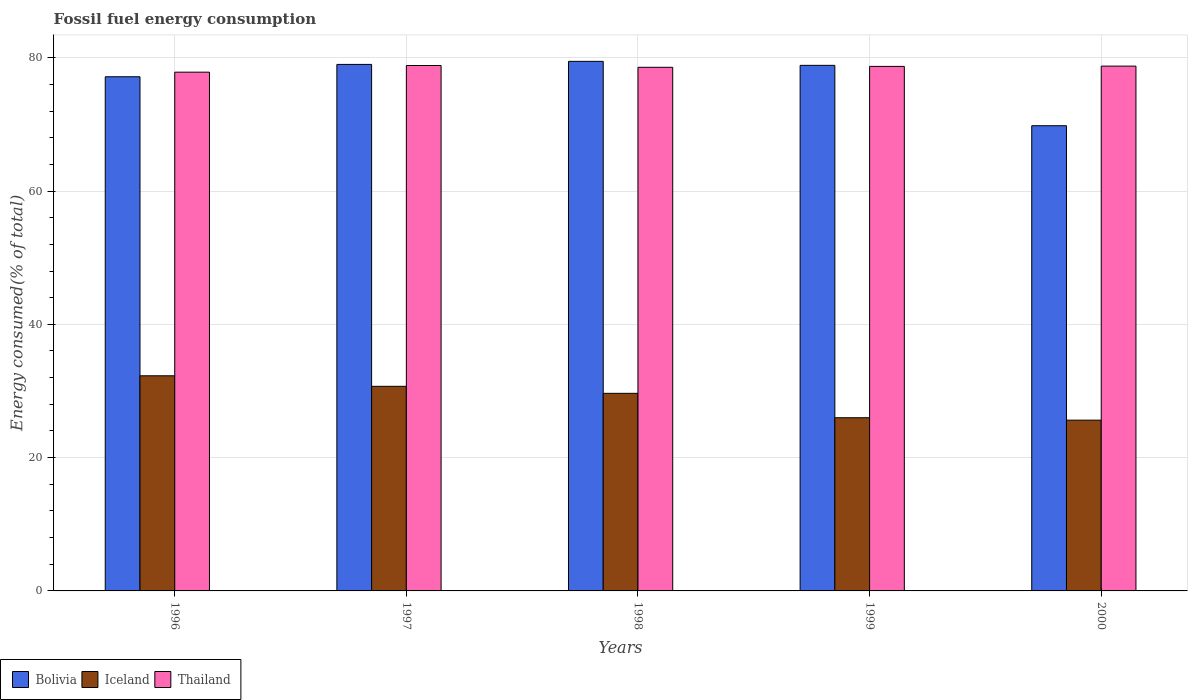How many different coloured bars are there?
Your answer should be compact. 3. How many bars are there on the 3rd tick from the left?
Your answer should be very brief. 3. How many bars are there on the 4th tick from the right?
Provide a succinct answer. 3. In how many cases, is the number of bars for a given year not equal to the number of legend labels?
Give a very brief answer. 0. What is the percentage of energy consumed in Thailand in 2000?
Keep it short and to the point. 78.74. Across all years, what is the maximum percentage of energy consumed in Thailand?
Keep it short and to the point. 78.84. Across all years, what is the minimum percentage of energy consumed in Iceland?
Provide a succinct answer. 25.62. In which year was the percentage of energy consumed in Iceland maximum?
Make the answer very short. 1996. In which year was the percentage of energy consumed in Iceland minimum?
Give a very brief answer. 2000. What is the total percentage of energy consumed in Bolivia in the graph?
Make the answer very short. 384.27. What is the difference between the percentage of energy consumed in Thailand in 1999 and that in 2000?
Offer a very short reply. -0.04. What is the difference between the percentage of energy consumed in Bolivia in 1997 and the percentage of energy consumed in Iceland in 1996?
Provide a short and direct response. 46.72. What is the average percentage of energy consumed in Bolivia per year?
Offer a very short reply. 76.85. In the year 1997, what is the difference between the percentage of energy consumed in Iceland and percentage of energy consumed in Bolivia?
Provide a short and direct response. -48.3. What is the ratio of the percentage of energy consumed in Bolivia in 1996 to that in 1997?
Provide a short and direct response. 0.98. Is the percentage of energy consumed in Thailand in 1996 less than that in 2000?
Offer a very short reply. Yes. What is the difference between the highest and the second highest percentage of energy consumed in Bolivia?
Make the answer very short. 0.46. What is the difference between the highest and the lowest percentage of energy consumed in Thailand?
Ensure brevity in your answer.  1. What does the 3rd bar from the left in 1998 represents?
Offer a very short reply. Thailand. Is it the case that in every year, the sum of the percentage of energy consumed in Thailand and percentage of energy consumed in Bolivia is greater than the percentage of energy consumed in Iceland?
Give a very brief answer. Yes. How many years are there in the graph?
Ensure brevity in your answer.  5. What is the difference between two consecutive major ticks on the Y-axis?
Give a very brief answer. 20. Does the graph contain any zero values?
Provide a succinct answer. No. Does the graph contain grids?
Offer a terse response. Yes. Where does the legend appear in the graph?
Ensure brevity in your answer.  Bottom left. How are the legend labels stacked?
Provide a succinct answer. Horizontal. What is the title of the graph?
Provide a succinct answer. Fossil fuel energy consumption. Does "Micronesia" appear as one of the legend labels in the graph?
Make the answer very short. No. What is the label or title of the Y-axis?
Make the answer very short. Energy consumed(% of total). What is the Energy consumed(% of total) in Bolivia in 1996?
Provide a succinct answer. 77.15. What is the Energy consumed(% of total) of Iceland in 1996?
Make the answer very short. 32.28. What is the Energy consumed(% of total) of Thailand in 1996?
Offer a terse response. 77.84. What is the Energy consumed(% of total) in Bolivia in 1997?
Offer a terse response. 79. What is the Energy consumed(% of total) of Iceland in 1997?
Provide a short and direct response. 30.7. What is the Energy consumed(% of total) in Thailand in 1997?
Offer a terse response. 78.84. What is the Energy consumed(% of total) of Bolivia in 1998?
Your response must be concise. 79.46. What is the Energy consumed(% of total) of Iceland in 1998?
Your answer should be compact. 29.65. What is the Energy consumed(% of total) of Thailand in 1998?
Offer a very short reply. 78.57. What is the Energy consumed(% of total) in Bolivia in 1999?
Your response must be concise. 78.86. What is the Energy consumed(% of total) in Iceland in 1999?
Provide a succinct answer. 25.99. What is the Energy consumed(% of total) of Thailand in 1999?
Give a very brief answer. 78.7. What is the Energy consumed(% of total) of Bolivia in 2000?
Provide a short and direct response. 69.8. What is the Energy consumed(% of total) in Iceland in 2000?
Provide a succinct answer. 25.62. What is the Energy consumed(% of total) in Thailand in 2000?
Your answer should be compact. 78.74. Across all years, what is the maximum Energy consumed(% of total) of Bolivia?
Your answer should be compact. 79.46. Across all years, what is the maximum Energy consumed(% of total) in Iceland?
Your answer should be compact. 32.28. Across all years, what is the maximum Energy consumed(% of total) of Thailand?
Ensure brevity in your answer.  78.84. Across all years, what is the minimum Energy consumed(% of total) of Bolivia?
Provide a short and direct response. 69.8. Across all years, what is the minimum Energy consumed(% of total) of Iceland?
Provide a short and direct response. 25.62. Across all years, what is the minimum Energy consumed(% of total) of Thailand?
Make the answer very short. 77.84. What is the total Energy consumed(% of total) of Bolivia in the graph?
Make the answer very short. 384.27. What is the total Energy consumed(% of total) of Iceland in the graph?
Give a very brief answer. 144.24. What is the total Energy consumed(% of total) of Thailand in the graph?
Your response must be concise. 392.68. What is the difference between the Energy consumed(% of total) of Bolivia in 1996 and that in 1997?
Your answer should be compact. -1.85. What is the difference between the Energy consumed(% of total) of Iceland in 1996 and that in 1997?
Your response must be concise. 1.58. What is the difference between the Energy consumed(% of total) of Thailand in 1996 and that in 1997?
Give a very brief answer. -1. What is the difference between the Energy consumed(% of total) in Bolivia in 1996 and that in 1998?
Provide a succinct answer. -2.31. What is the difference between the Energy consumed(% of total) of Iceland in 1996 and that in 1998?
Your response must be concise. 2.63. What is the difference between the Energy consumed(% of total) in Thailand in 1996 and that in 1998?
Provide a succinct answer. -0.73. What is the difference between the Energy consumed(% of total) in Bolivia in 1996 and that in 1999?
Keep it short and to the point. -1.71. What is the difference between the Energy consumed(% of total) of Iceland in 1996 and that in 1999?
Make the answer very short. 6.29. What is the difference between the Energy consumed(% of total) of Thailand in 1996 and that in 1999?
Provide a short and direct response. -0.87. What is the difference between the Energy consumed(% of total) of Bolivia in 1996 and that in 2000?
Your response must be concise. 7.35. What is the difference between the Energy consumed(% of total) in Iceland in 1996 and that in 2000?
Ensure brevity in your answer.  6.66. What is the difference between the Energy consumed(% of total) of Thailand in 1996 and that in 2000?
Make the answer very short. -0.91. What is the difference between the Energy consumed(% of total) in Bolivia in 1997 and that in 1998?
Offer a very short reply. -0.46. What is the difference between the Energy consumed(% of total) in Iceland in 1997 and that in 1998?
Offer a terse response. 1.05. What is the difference between the Energy consumed(% of total) in Thailand in 1997 and that in 1998?
Keep it short and to the point. 0.27. What is the difference between the Energy consumed(% of total) of Bolivia in 1997 and that in 1999?
Offer a terse response. 0.14. What is the difference between the Energy consumed(% of total) of Iceland in 1997 and that in 1999?
Offer a very short reply. 4.71. What is the difference between the Energy consumed(% of total) in Thailand in 1997 and that in 1999?
Give a very brief answer. 0.13. What is the difference between the Energy consumed(% of total) in Bolivia in 1997 and that in 2000?
Provide a short and direct response. 9.2. What is the difference between the Energy consumed(% of total) of Iceland in 1997 and that in 2000?
Ensure brevity in your answer.  5.08. What is the difference between the Energy consumed(% of total) in Thailand in 1997 and that in 2000?
Your answer should be very brief. 0.09. What is the difference between the Energy consumed(% of total) in Bolivia in 1998 and that in 1999?
Provide a short and direct response. 0.6. What is the difference between the Energy consumed(% of total) in Iceland in 1998 and that in 1999?
Your answer should be compact. 3.66. What is the difference between the Energy consumed(% of total) in Thailand in 1998 and that in 1999?
Keep it short and to the point. -0.14. What is the difference between the Energy consumed(% of total) of Bolivia in 1998 and that in 2000?
Your response must be concise. 9.66. What is the difference between the Energy consumed(% of total) of Iceland in 1998 and that in 2000?
Ensure brevity in your answer.  4.02. What is the difference between the Energy consumed(% of total) of Thailand in 1998 and that in 2000?
Make the answer very short. -0.18. What is the difference between the Energy consumed(% of total) in Bolivia in 1999 and that in 2000?
Offer a terse response. 9.06. What is the difference between the Energy consumed(% of total) in Iceland in 1999 and that in 2000?
Your answer should be compact. 0.37. What is the difference between the Energy consumed(% of total) in Thailand in 1999 and that in 2000?
Offer a terse response. -0.04. What is the difference between the Energy consumed(% of total) in Bolivia in 1996 and the Energy consumed(% of total) in Iceland in 1997?
Make the answer very short. 46.45. What is the difference between the Energy consumed(% of total) of Bolivia in 1996 and the Energy consumed(% of total) of Thailand in 1997?
Ensure brevity in your answer.  -1.69. What is the difference between the Energy consumed(% of total) in Iceland in 1996 and the Energy consumed(% of total) in Thailand in 1997?
Make the answer very short. -46.56. What is the difference between the Energy consumed(% of total) of Bolivia in 1996 and the Energy consumed(% of total) of Iceland in 1998?
Keep it short and to the point. 47.5. What is the difference between the Energy consumed(% of total) in Bolivia in 1996 and the Energy consumed(% of total) in Thailand in 1998?
Your response must be concise. -1.42. What is the difference between the Energy consumed(% of total) in Iceland in 1996 and the Energy consumed(% of total) in Thailand in 1998?
Ensure brevity in your answer.  -46.29. What is the difference between the Energy consumed(% of total) in Bolivia in 1996 and the Energy consumed(% of total) in Iceland in 1999?
Your answer should be compact. 51.16. What is the difference between the Energy consumed(% of total) of Bolivia in 1996 and the Energy consumed(% of total) of Thailand in 1999?
Offer a very short reply. -1.55. What is the difference between the Energy consumed(% of total) of Iceland in 1996 and the Energy consumed(% of total) of Thailand in 1999?
Offer a very short reply. -46.42. What is the difference between the Energy consumed(% of total) in Bolivia in 1996 and the Energy consumed(% of total) in Iceland in 2000?
Keep it short and to the point. 51.52. What is the difference between the Energy consumed(% of total) of Bolivia in 1996 and the Energy consumed(% of total) of Thailand in 2000?
Keep it short and to the point. -1.6. What is the difference between the Energy consumed(% of total) in Iceland in 1996 and the Energy consumed(% of total) in Thailand in 2000?
Your answer should be very brief. -46.46. What is the difference between the Energy consumed(% of total) of Bolivia in 1997 and the Energy consumed(% of total) of Iceland in 1998?
Offer a terse response. 49.35. What is the difference between the Energy consumed(% of total) in Bolivia in 1997 and the Energy consumed(% of total) in Thailand in 1998?
Your response must be concise. 0.43. What is the difference between the Energy consumed(% of total) in Iceland in 1997 and the Energy consumed(% of total) in Thailand in 1998?
Provide a succinct answer. -47.87. What is the difference between the Energy consumed(% of total) in Bolivia in 1997 and the Energy consumed(% of total) in Iceland in 1999?
Your answer should be very brief. 53.01. What is the difference between the Energy consumed(% of total) of Bolivia in 1997 and the Energy consumed(% of total) of Thailand in 1999?
Provide a succinct answer. 0.3. What is the difference between the Energy consumed(% of total) in Iceland in 1997 and the Energy consumed(% of total) in Thailand in 1999?
Ensure brevity in your answer.  -48. What is the difference between the Energy consumed(% of total) in Bolivia in 1997 and the Energy consumed(% of total) in Iceland in 2000?
Provide a short and direct response. 53.38. What is the difference between the Energy consumed(% of total) of Bolivia in 1997 and the Energy consumed(% of total) of Thailand in 2000?
Keep it short and to the point. 0.26. What is the difference between the Energy consumed(% of total) of Iceland in 1997 and the Energy consumed(% of total) of Thailand in 2000?
Provide a short and direct response. -48.04. What is the difference between the Energy consumed(% of total) in Bolivia in 1998 and the Energy consumed(% of total) in Iceland in 1999?
Provide a succinct answer. 53.47. What is the difference between the Energy consumed(% of total) in Bolivia in 1998 and the Energy consumed(% of total) in Thailand in 1999?
Offer a terse response. 0.76. What is the difference between the Energy consumed(% of total) of Iceland in 1998 and the Energy consumed(% of total) of Thailand in 1999?
Provide a short and direct response. -49.05. What is the difference between the Energy consumed(% of total) in Bolivia in 1998 and the Energy consumed(% of total) in Iceland in 2000?
Your answer should be very brief. 53.84. What is the difference between the Energy consumed(% of total) of Bolivia in 1998 and the Energy consumed(% of total) of Thailand in 2000?
Your response must be concise. 0.72. What is the difference between the Energy consumed(% of total) of Iceland in 1998 and the Energy consumed(% of total) of Thailand in 2000?
Your response must be concise. -49.1. What is the difference between the Energy consumed(% of total) of Bolivia in 1999 and the Energy consumed(% of total) of Iceland in 2000?
Ensure brevity in your answer.  53.24. What is the difference between the Energy consumed(% of total) in Bolivia in 1999 and the Energy consumed(% of total) in Thailand in 2000?
Provide a succinct answer. 0.12. What is the difference between the Energy consumed(% of total) in Iceland in 1999 and the Energy consumed(% of total) in Thailand in 2000?
Ensure brevity in your answer.  -52.76. What is the average Energy consumed(% of total) of Bolivia per year?
Offer a terse response. 76.85. What is the average Energy consumed(% of total) in Iceland per year?
Your response must be concise. 28.85. What is the average Energy consumed(% of total) in Thailand per year?
Make the answer very short. 78.54. In the year 1996, what is the difference between the Energy consumed(% of total) in Bolivia and Energy consumed(% of total) in Iceland?
Give a very brief answer. 44.87. In the year 1996, what is the difference between the Energy consumed(% of total) in Bolivia and Energy consumed(% of total) in Thailand?
Make the answer very short. -0.69. In the year 1996, what is the difference between the Energy consumed(% of total) of Iceland and Energy consumed(% of total) of Thailand?
Provide a short and direct response. -45.56. In the year 1997, what is the difference between the Energy consumed(% of total) in Bolivia and Energy consumed(% of total) in Iceland?
Make the answer very short. 48.3. In the year 1997, what is the difference between the Energy consumed(% of total) of Bolivia and Energy consumed(% of total) of Thailand?
Ensure brevity in your answer.  0.16. In the year 1997, what is the difference between the Energy consumed(% of total) of Iceland and Energy consumed(% of total) of Thailand?
Provide a short and direct response. -48.14. In the year 1998, what is the difference between the Energy consumed(% of total) of Bolivia and Energy consumed(% of total) of Iceland?
Offer a very short reply. 49.81. In the year 1998, what is the difference between the Energy consumed(% of total) in Bolivia and Energy consumed(% of total) in Thailand?
Offer a terse response. 0.89. In the year 1998, what is the difference between the Energy consumed(% of total) in Iceland and Energy consumed(% of total) in Thailand?
Offer a terse response. -48.92. In the year 1999, what is the difference between the Energy consumed(% of total) in Bolivia and Energy consumed(% of total) in Iceland?
Your response must be concise. 52.87. In the year 1999, what is the difference between the Energy consumed(% of total) of Bolivia and Energy consumed(% of total) of Thailand?
Provide a succinct answer. 0.16. In the year 1999, what is the difference between the Energy consumed(% of total) of Iceland and Energy consumed(% of total) of Thailand?
Your response must be concise. -52.71. In the year 2000, what is the difference between the Energy consumed(% of total) of Bolivia and Energy consumed(% of total) of Iceland?
Give a very brief answer. 44.18. In the year 2000, what is the difference between the Energy consumed(% of total) of Bolivia and Energy consumed(% of total) of Thailand?
Offer a very short reply. -8.94. In the year 2000, what is the difference between the Energy consumed(% of total) in Iceland and Energy consumed(% of total) in Thailand?
Your answer should be compact. -53.12. What is the ratio of the Energy consumed(% of total) in Bolivia in 1996 to that in 1997?
Your answer should be compact. 0.98. What is the ratio of the Energy consumed(% of total) in Iceland in 1996 to that in 1997?
Your response must be concise. 1.05. What is the ratio of the Energy consumed(% of total) in Thailand in 1996 to that in 1997?
Your answer should be very brief. 0.99. What is the ratio of the Energy consumed(% of total) in Bolivia in 1996 to that in 1998?
Keep it short and to the point. 0.97. What is the ratio of the Energy consumed(% of total) of Iceland in 1996 to that in 1998?
Provide a succinct answer. 1.09. What is the ratio of the Energy consumed(% of total) of Thailand in 1996 to that in 1998?
Your response must be concise. 0.99. What is the ratio of the Energy consumed(% of total) of Bolivia in 1996 to that in 1999?
Your answer should be very brief. 0.98. What is the ratio of the Energy consumed(% of total) in Iceland in 1996 to that in 1999?
Your response must be concise. 1.24. What is the ratio of the Energy consumed(% of total) in Thailand in 1996 to that in 1999?
Provide a short and direct response. 0.99. What is the ratio of the Energy consumed(% of total) of Bolivia in 1996 to that in 2000?
Your answer should be very brief. 1.11. What is the ratio of the Energy consumed(% of total) in Iceland in 1996 to that in 2000?
Offer a very short reply. 1.26. What is the ratio of the Energy consumed(% of total) of Thailand in 1996 to that in 2000?
Your response must be concise. 0.99. What is the ratio of the Energy consumed(% of total) in Bolivia in 1997 to that in 1998?
Offer a very short reply. 0.99. What is the ratio of the Energy consumed(% of total) in Iceland in 1997 to that in 1998?
Offer a very short reply. 1.04. What is the ratio of the Energy consumed(% of total) of Thailand in 1997 to that in 1998?
Provide a succinct answer. 1. What is the ratio of the Energy consumed(% of total) of Bolivia in 1997 to that in 1999?
Ensure brevity in your answer.  1. What is the ratio of the Energy consumed(% of total) in Iceland in 1997 to that in 1999?
Offer a terse response. 1.18. What is the ratio of the Energy consumed(% of total) of Bolivia in 1997 to that in 2000?
Offer a very short reply. 1.13. What is the ratio of the Energy consumed(% of total) in Iceland in 1997 to that in 2000?
Provide a succinct answer. 1.2. What is the ratio of the Energy consumed(% of total) in Thailand in 1997 to that in 2000?
Your answer should be compact. 1. What is the ratio of the Energy consumed(% of total) in Bolivia in 1998 to that in 1999?
Give a very brief answer. 1.01. What is the ratio of the Energy consumed(% of total) in Iceland in 1998 to that in 1999?
Keep it short and to the point. 1.14. What is the ratio of the Energy consumed(% of total) of Thailand in 1998 to that in 1999?
Your response must be concise. 1. What is the ratio of the Energy consumed(% of total) of Bolivia in 1998 to that in 2000?
Your answer should be compact. 1.14. What is the ratio of the Energy consumed(% of total) in Iceland in 1998 to that in 2000?
Provide a succinct answer. 1.16. What is the ratio of the Energy consumed(% of total) in Bolivia in 1999 to that in 2000?
Your answer should be very brief. 1.13. What is the ratio of the Energy consumed(% of total) in Iceland in 1999 to that in 2000?
Give a very brief answer. 1.01. What is the difference between the highest and the second highest Energy consumed(% of total) in Bolivia?
Offer a very short reply. 0.46. What is the difference between the highest and the second highest Energy consumed(% of total) of Iceland?
Give a very brief answer. 1.58. What is the difference between the highest and the second highest Energy consumed(% of total) in Thailand?
Offer a terse response. 0.09. What is the difference between the highest and the lowest Energy consumed(% of total) in Bolivia?
Give a very brief answer. 9.66. What is the difference between the highest and the lowest Energy consumed(% of total) of Iceland?
Provide a succinct answer. 6.66. What is the difference between the highest and the lowest Energy consumed(% of total) in Thailand?
Offer a very short reply. 1. 